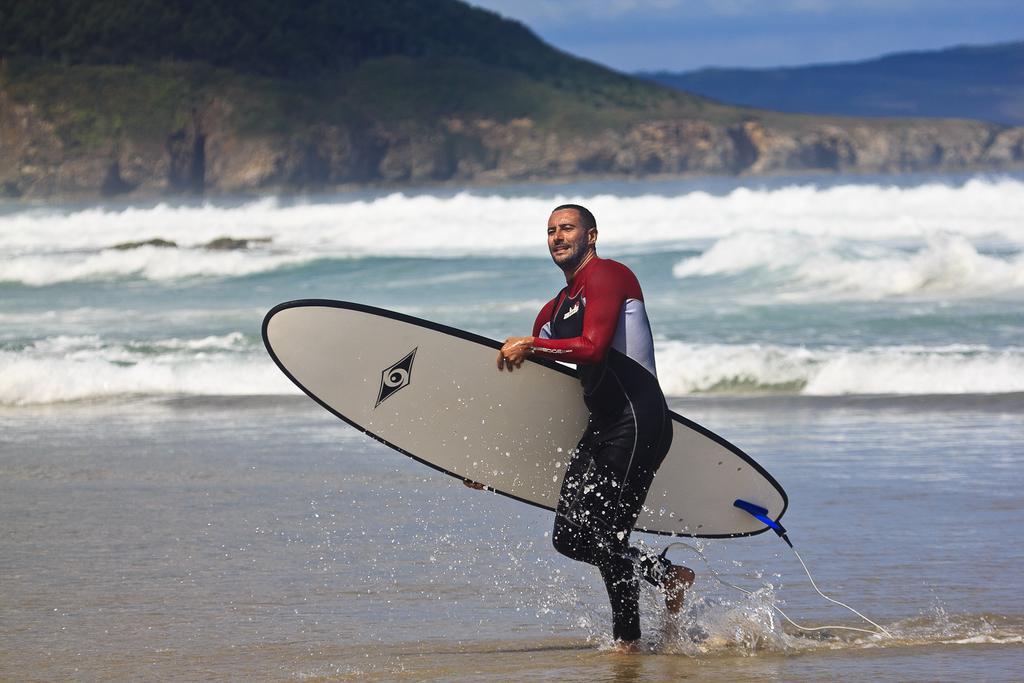In one or two sentences, can you explain what this image depicts? In this image we can see a man is holding a surfboard in his hands and walking in the water. In the background we can see water, mountains and clouds in the sky. 